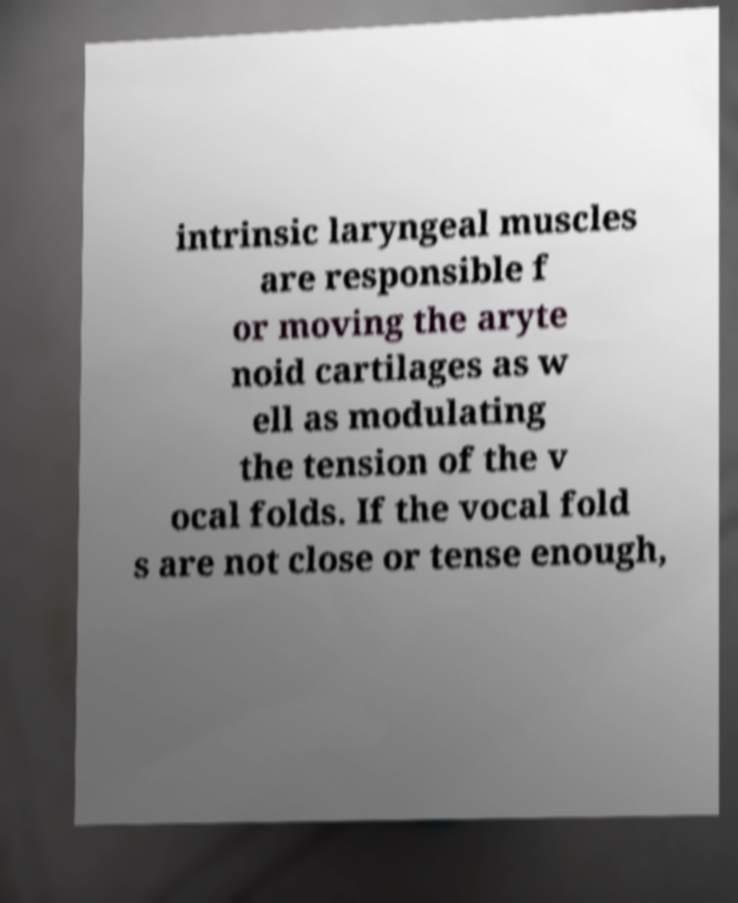Could you extract and type out the text from this image? intrinsic laryngeal muscles are responsible f or moving the aryte noid cartilages as w ell as modulating the tension of the v ocal folds. If the vocal fold s are not close or tense enough, 